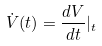<formula> <loc_0><loc_0><loc_500><loc_500>\dot { V } ( t ) = \frac { d V } { d t } | _ { t }</formula> 